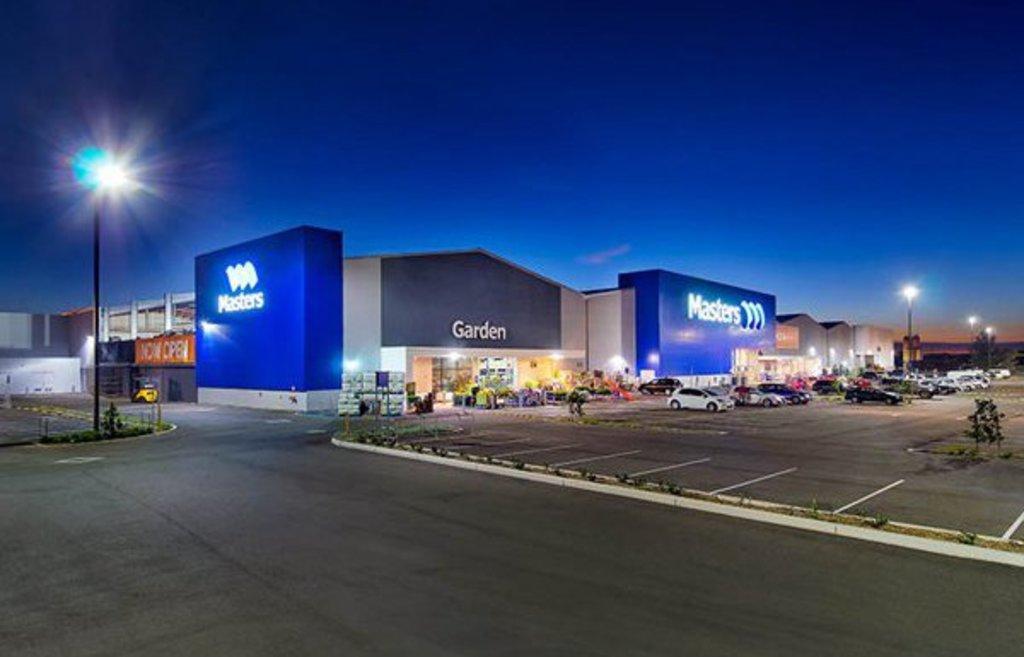In one or two sentences, can you explain what this image depicts? In this image, we can see warehouses and street poles. There are vehicles on the right side of the image. There is a sky at the top of the image. 